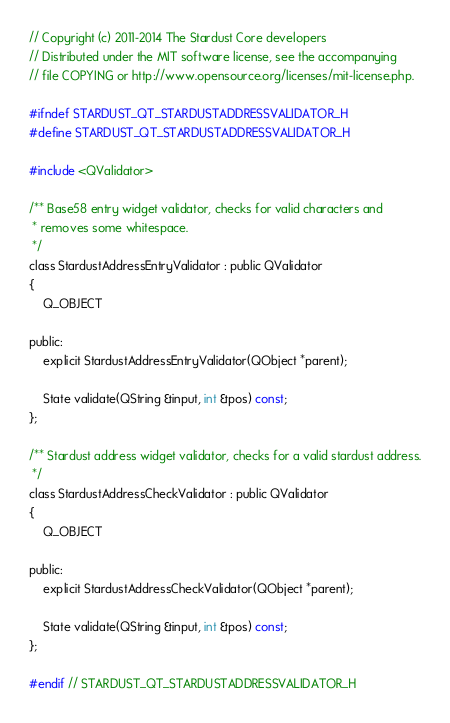Convert code to text. <code><loc_0><loc_0><loc_500><loc_500><_C_>// Copyright (c) 2011-2014 The Stardust Core developers
// Distributed under the MIT software license, see the accompanying
// file COPYING or http://www.opensource.org/licenses/mit-license.php.

#ifndef STARDUST_QT_STARDUSTADDRESSVALIDATOR_H
#define STARDUST_QT_STARDUSTADDRESSVALIDATOR_H

#include <QValidator>

/** Base58 entry widget validator, checks for valid characters and
 * removes some whitespace.
 */
class StardustAddressEntryValidator : public QValidator
{
    Q_OBJECT

public:
    explicit StardustAddressEntryValidator(QObject *parent);

    State validate(QString &input, int &pos) const;
};

/** Stardust address widget validator, checks for a valid stardust address.
 */
class StardustAddressCheckValidator : public QValidator
{
    Q_OBJECT

public:
    explicit StardustAddressCheckValidator(QObject *parent);

    State validate(QString &input, int &pos) const;
};

#endif // STARDUST_QT_STARDUSTADDRESSVALIDATOR_H
</code> 